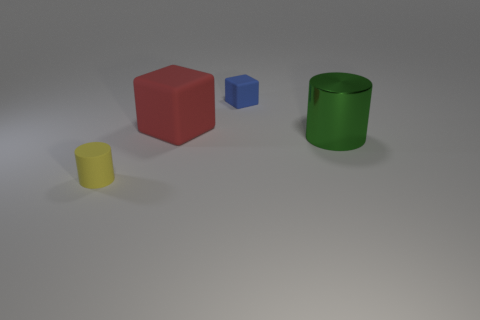Is there any other thing that is made of the same material as the big green cylinder?
Your answer should be compact. No. The object that is behind the yellow thing and in front of the large rubber block is made of what material?
Provide a short and direct response. Metal. What number of other big rubber objects have the same shape as the yellow object?
Your answer should be very brief. 0. What is the color of the small matte thing behind the small object to the left of the blue rubber object?
Give a very brief answer. Blue. Are there the same number of green shiny things that are in front of the yellow rubber thing and big cyan cylinders?
Offer a very short reply. Yes. Are there any objects that have the same size as the yellow matte cylinder?
Offer a very short reply. Yes. There is a green metallic cylinder; is it the same size as the blue matte object that is right of the big red thing?
Make the answer very short. No. Are there an equal number of large green metallic cylinders to the left of the tiny rubber cylinder and things behind the metallic cylinder?
Provide a short and direct response. No. There is a tiny thing on the left side of the large cube; what is its material?
Give a very brief answer. Rubber. Is the size of the red rubber thing the same as the green shiny object?
Offer a very short reply. Yes. 